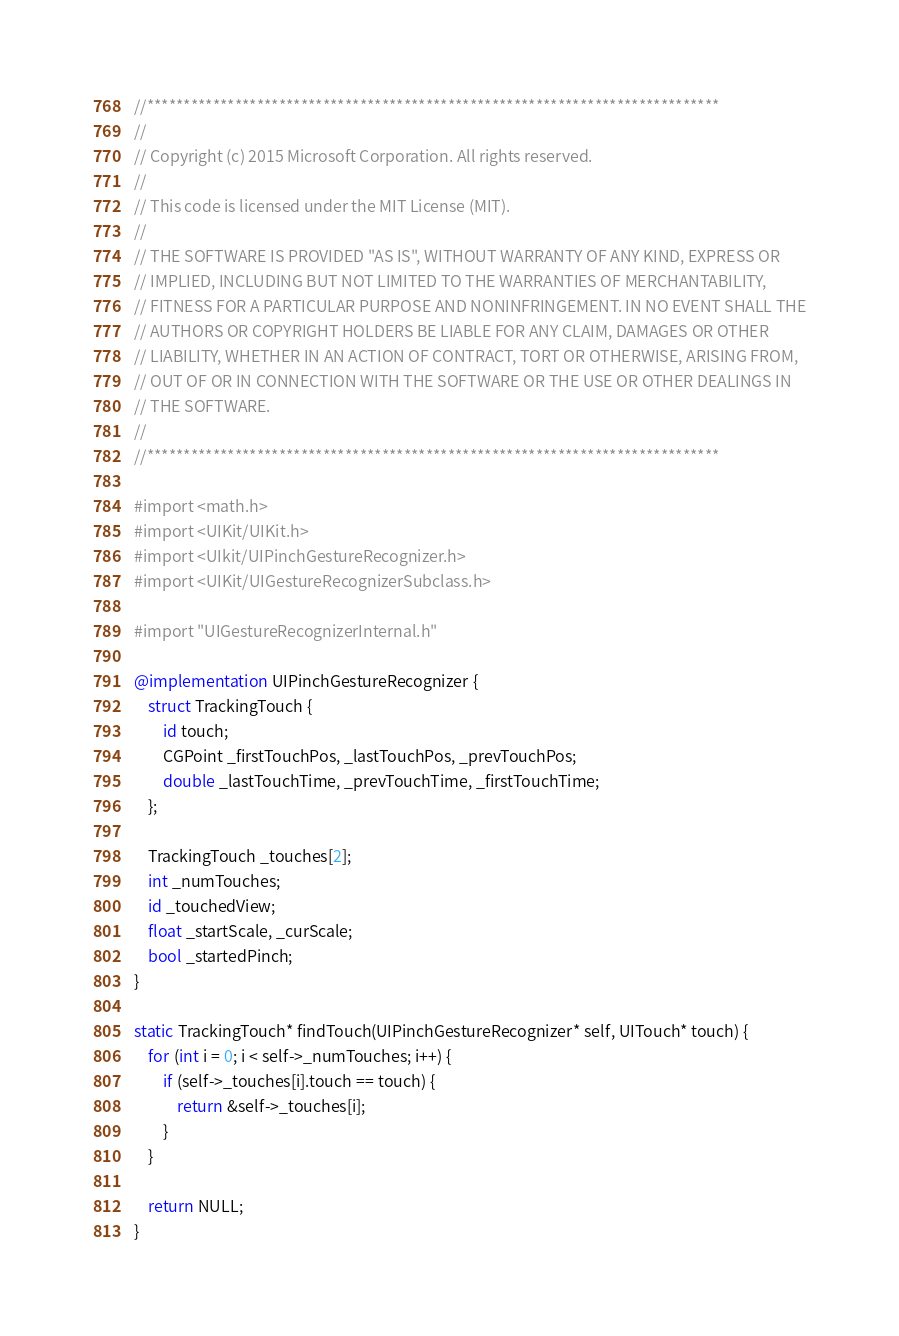Convert code to text. <code><loc_0><loc_0><loc_500><loc_500><_ObjectiveC_>//******************************************************************************
//
// Copyright (c) 2015 Microsoft Corporation. All rights reserved.
//
// This code is licensed under the MIT License (MIT).
//
// THE SOFTWARE IS PROVIDED "AS IS", WITHOUT WARRANTY OF ANY KIND, EXPRESS OR
// IMPLIED, INCLUDING BUT NOT LIMITED TO THE WARRANTIES OF MERCHANTABILITY,
// FITNESS FOR A PARTICULAR PURPOSE AND NONINFRINGEMENT. IN NO EVENT SHALL THE
// AUTHORS OR COPYRIGHT HOLDERS BE LIABLE FOR ANY CLAIM, DAMAGES OR OTHER
// LIABILITY, WHETHER IN AN ACTION OF CONTRACT, TORT OR OTHERWISE, ARISING FROM,
// OUT OF OR IN CONNECTION WITH THE SOFTWARE OR THE USE OR OTHER DEALINGS IN
// THE SOFTWARE.
//
//******************************************************************************

#import <math.h>
#import <UIKit/UIKit.h>
#import <UIkit/UIPinchGestureRecognizer.h>
#import <UIKit/UIGestureRecognizerSubclass.h>

#import "UIGestureRecognizerInternal.h"

@implementation UIPinchGestureRecognizer {
    struct TrackingTouch {
        id touch;
        CGPoint _firstTouchPos, _lastTouchPos, _prevTouchPos;
        double _lastTouchTime, _prevTouchTime, _firstTouchTime;
    };

    TrackingTouch _touches[2];
    int _numTouches;
    id _touchedView;
    float _startScale, _curScale;
    bool _startedPinch;
}

static TrackingTouch* findTouch(UIPinchGestureRecognizer* self, UITouch* touch) {
    for (int i = 0; i < self->_numTouches; i++) {
        if (self->_touches[i].touch == touch) {
            return &self->_touches[i];
        }
    }

    return NULL;
}
</code> 